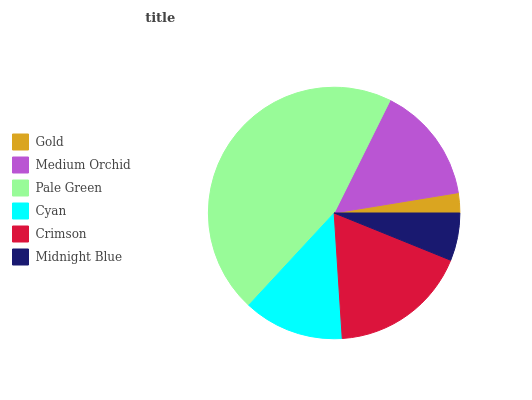Is Gold the minimum?
Answer yes or no. Yes. Is Pale Green the maximum?
Answer yes or no. Yes. Is Medium Orchid the minimum?
Answer yes or no. No. Is Medium Orchid the maximum?
Answer yes or no. No. Is Medium Orchid greater than Gold?
Answer yes or no. Yes. Is Gold less than Medium Orchid?
Answer yes or no. Yes. Is Gold greater than Medium Orchid?
Answer yes or no. No. Is Medium Orchid less than Gold?
Answer yes or no. No. Is Medium Orchid the high median?
Answer yes or no. Yes. Is Cyan the low median?
Answer yes or no. Yes. Is Cyan the high median?
Answer yes or no. No. Is Pale Green the low median?
Answer yes or no. No. 